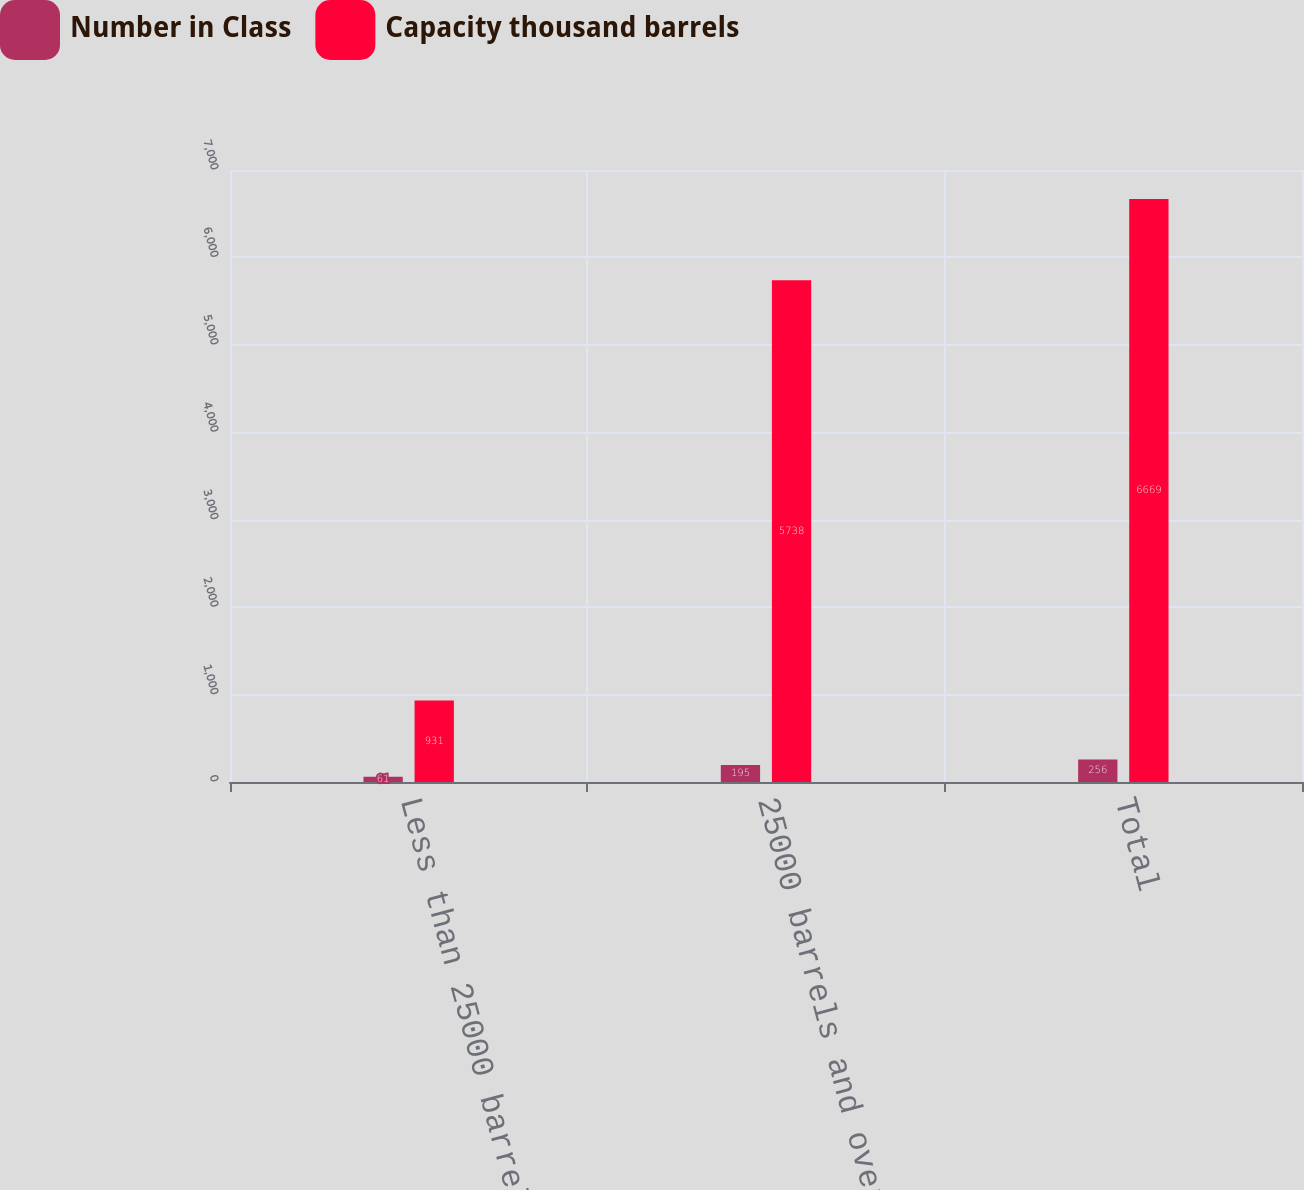<chart> <loc_0><loc_0><loc_500><loc_500><stacked_bar_chart><ecel><fcel>Less than 25000 barrels<fcel>25000 barrels and over<fcel>Total<nl><fcel>Number in Class<fcel>61<fcel>195<fcel>256<nl><fcel>Capacity thousand barrels<fcel>931<fcel>5738<fcel>6669<nl></chart> 